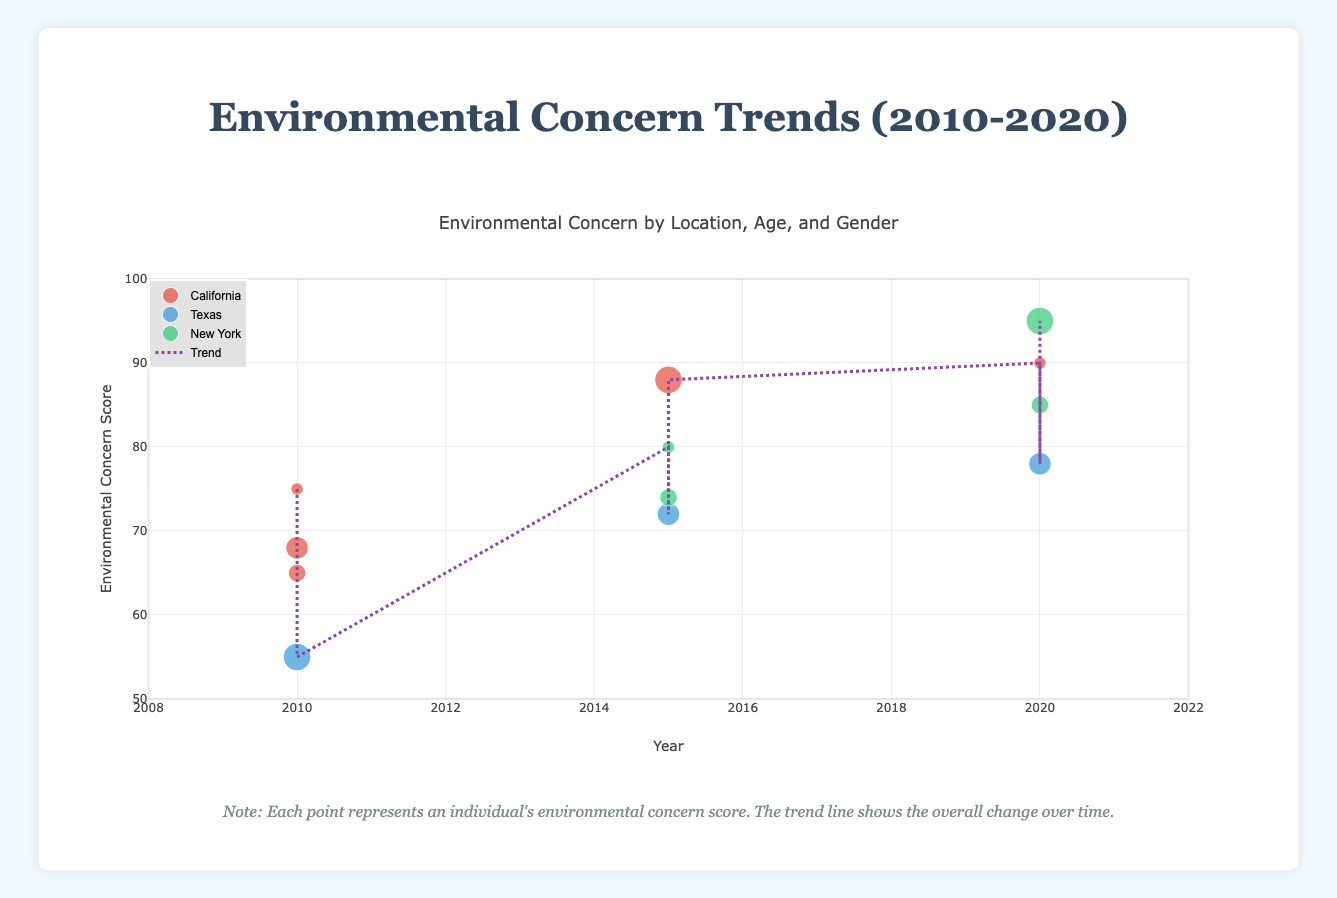What is the title of the figure? Look at the top of the figure where the title is typically located.
Answer: Environmental Concern Trends (2010-2020) What is the range of the x-axis? Observe the x-axis at the bottom of the plot. The range starts from 2008 and ends at 2022.
Answer: 2008-2022 Which location has the highest environmental concern score in 2020? Identify the data points for each location in 2020 and compare their environmental concern scores. New York has a score of 95, which is the highest.
Answer: New York What is the general trend indicated by the trend line? Look at the trend line and observe its overall direction. The trend line is increasing, indicating that environmental concern has generally risen over time.
Answer: Increasing How does the environmental concern for females in California change from 2010 to 2020? Compare the environmental concern scores for females in California for the years 2010 (75) and 2020 (90).
Answer: It increases from 75 to 90 What is the average environmental concern score in 2015 across all locations? Sum up the scores in 2015 (80, 74, 72, 88) and divide by the number of data points (4). The average is (80 + 74 + 72 + 88) / 4 = 78.5.
Answer: 78.5 Which gender has the higher environmental concern score in California in 2020? Compare the scores of males and females in California for 2020. Females have 90 and there are no males data visible for 2020 in California, so by default, it's females.
Answer: Female How many data points represent California in the entire figure? Count the number of points labeled as "California" in the data and plot (4 in total).
Answer: 4 What is the youngest age group’s environmental concern score in New York in 2015? Identify the youngest age group (25) in New York in 2015 and look at their environmental concern score (80).
Answer: 80 Between which years is the increase in environmental concern the highest based on the trend line? Compare the slope of the trend line between different pairs of subsequent years and identify the steepest segment. Between 2015 and 2020, the increase is highest.
Answer: 2015-2020 